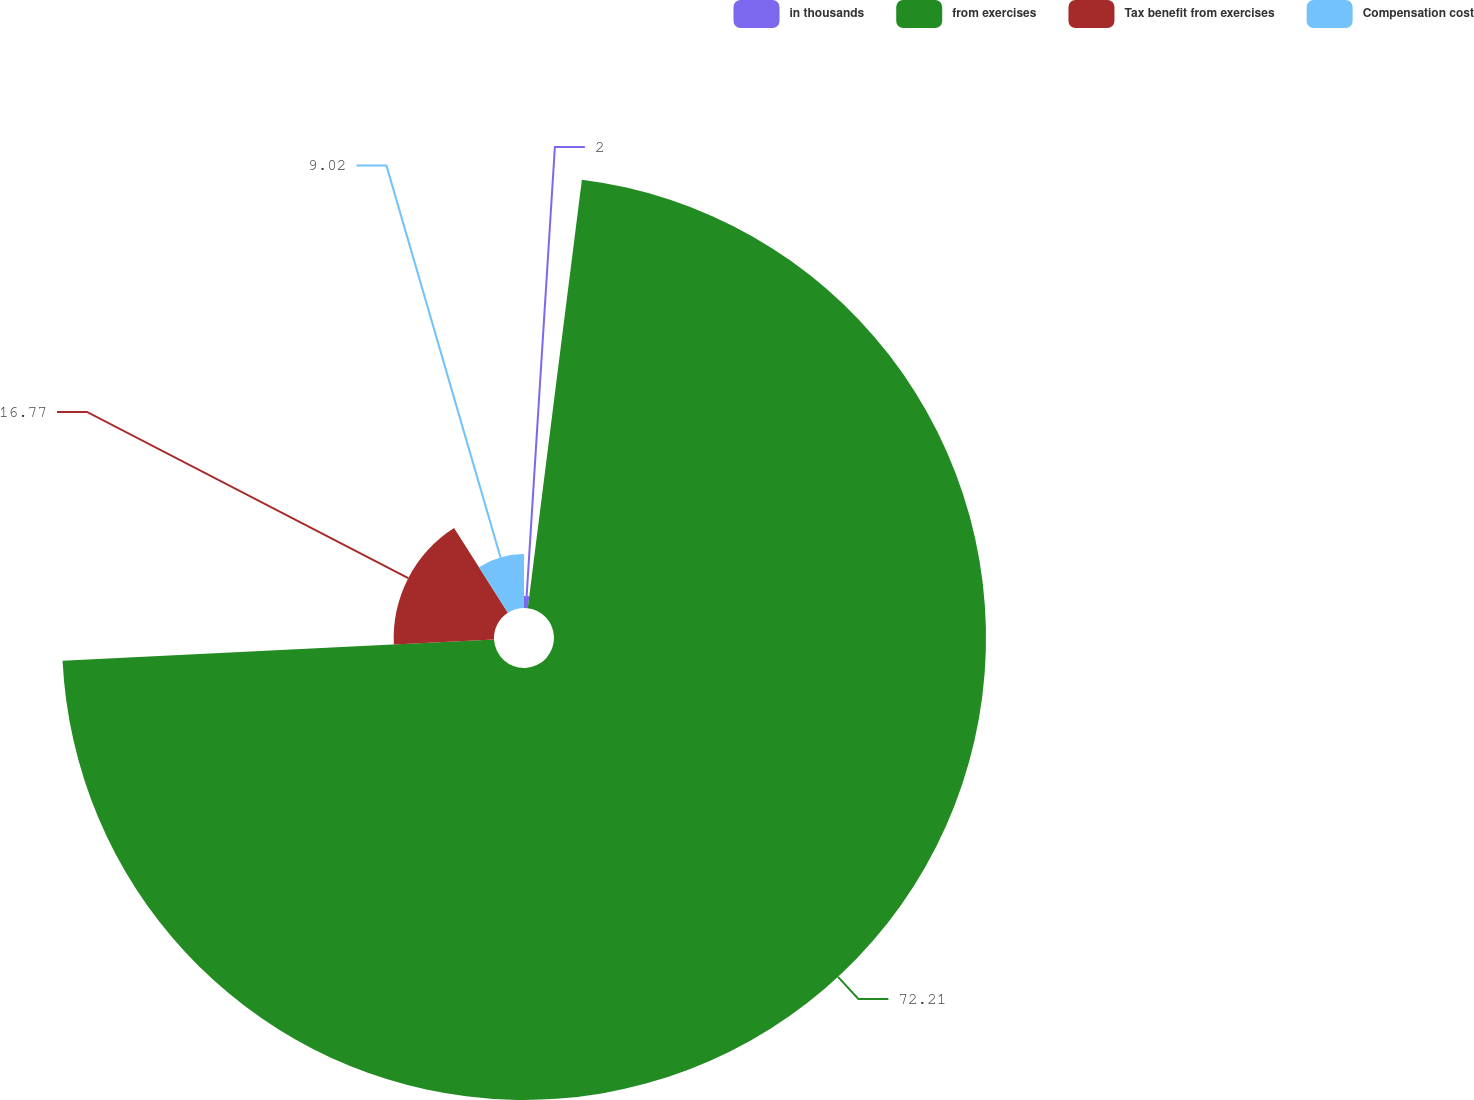Convert chart. <chart><loc_0><loc_0><loc_500><loc_500><pie_chart><fcel>in thousands<fcel>from exercises<fcel>Tax benefit from exercises<fcel>Compensation cost<nl><fcel>2.0%<fcel>72.22%<fcel>16.77%<fcel>9.02%<nl></chart> 